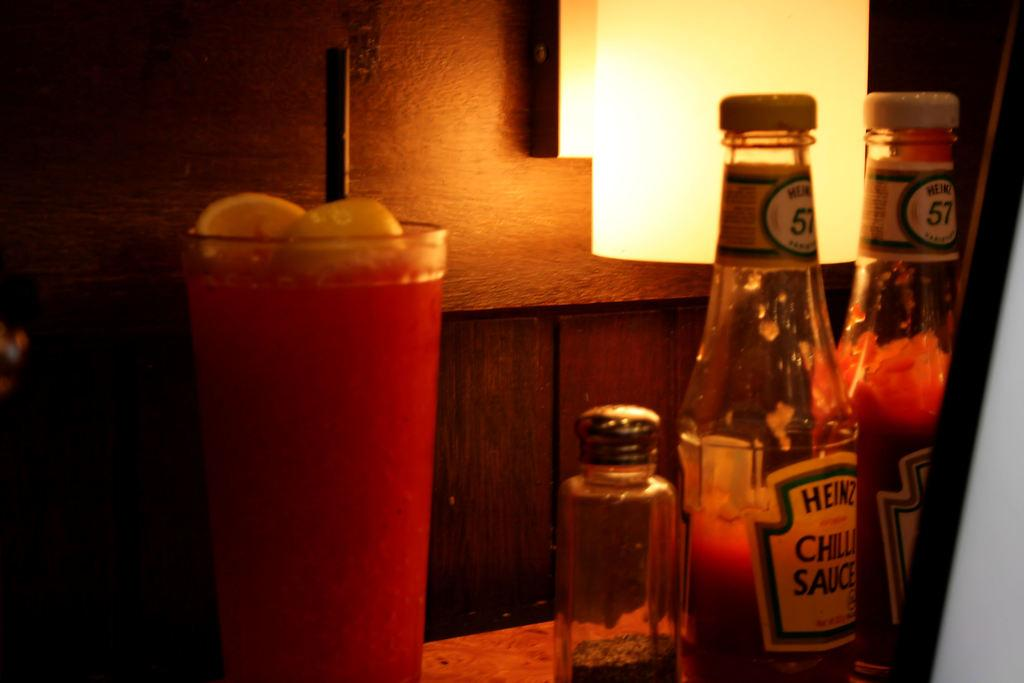<image>
Create a compact narrative representing the image presented. A bottle of Heinz ketchup next to a drink. 